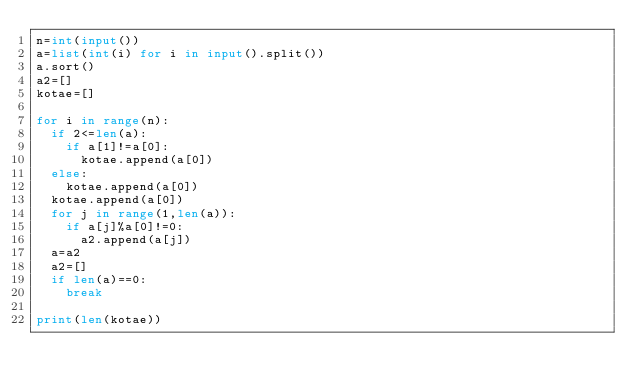Convert code to text. <code><loc_0><loc_0><loc_500><loc_500><_Python_>n=int(input())
a=list(int(i) for i in input().split())
a.sort()
a2=[]
kotae=[]

for i in range(n):
  if 2<=len(a):
    if a[1]!=a[0]:
      kotae.append(a[0])
  else:
    kotae.append(a[0])
  kotae.append(a[0])
  for j in range(1,len(a)):
    if a[j]%a[0]!=0:
      a2.append(a[j])
  a=a2
  a2=[]
  if len(a)==0:
    break
       
print(len(kotae))</code> 